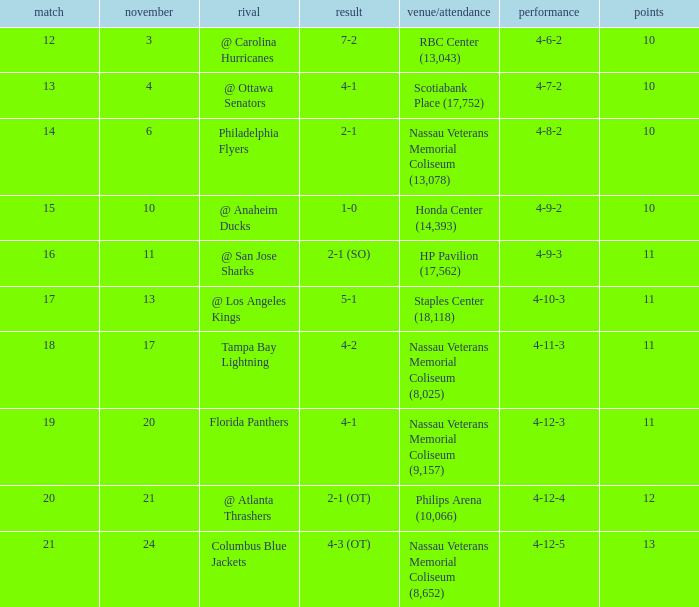What is every game on November 21? 20.0. 